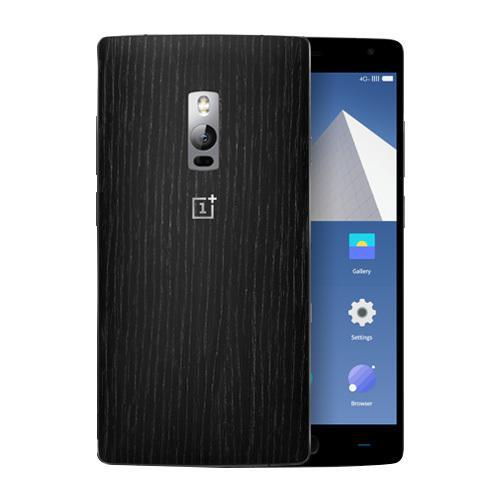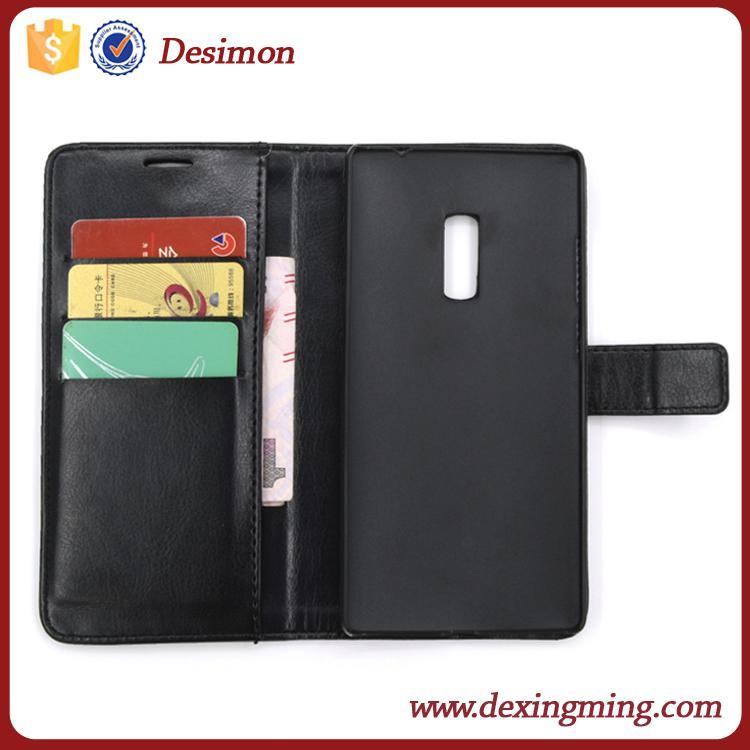The first image is the image on the left, the second image is the image on the right. Considering the images on both sides, is "The right image shows a wallet phone case that is open with no cell phone in it." valid? Answer yes or no. Yes. The first image is the image on the left, the second image is the image on the right. Given the left and right images, does the statement "The left and right image contains the same number of cell phones." hold true? Answer yes or no. No. 